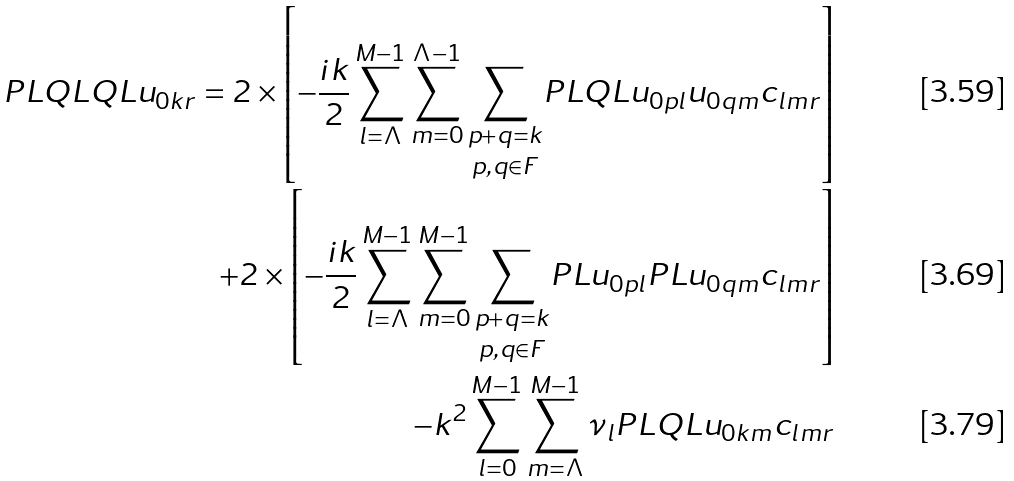<formula> <loc_0><loc_0><loc_500><loc_500>P L Q L Q L u _ { 0 k r } = 2 \times \left [ - \frac { i k } { 2 } \sum _ { l = \Lambda } ^ { M - 1 } \sum _ { m = 0 } ^ { \Lambda - 1 } \underset { p , q \in F } { \underset { p + q = k } { \sum } } P L Q L u _ { 0 p l } u _ { 0 q m } c _ { l m r } \right ] \\ + 2 \times \left [ - \frac { i k } { 2 } \sum _ { l = \Lambda } ^ { M - 1 } \sum _ { m = 0 } ^ { M - 1 } \underset { p , q \in F } { \underset { p + q = k } { \sum } } P L u _ { 0 p l } P L u _ { 0 q m } c _ { l m r } \right ] \\ - k ^ { 2 } \sum _ { l = 0 } ^ { M - 1 } \sum _ { m = \Lambda } ^ { M - 1 } \nu _ { l } P L Q L u _ { 0 k m } c _ { l m r }</formula> 